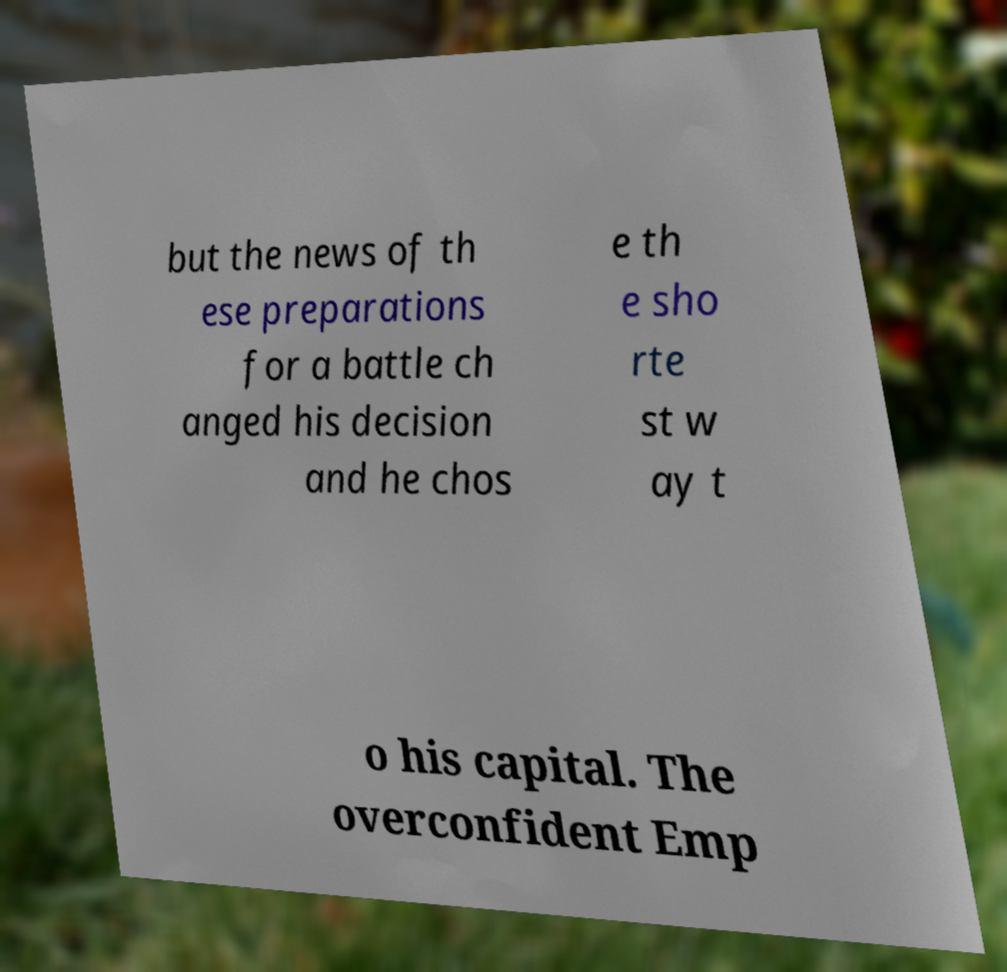There's text embedded in this image that I need extracted. Can you transcribe it verbatim? but the news of th ese preparations for a battle ch anged his decision and he chos e th e sho rte st w ay t o his capital. The overconfident Emp 